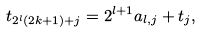<formula> <loc_0><loc_0><loc_500><loc_500>t _ { 2 ^ { l } ( 2 k + 1 ) + j } = 2 ^ { l + 1 } a _ { l , j } + t _ { j } ,</formula> 